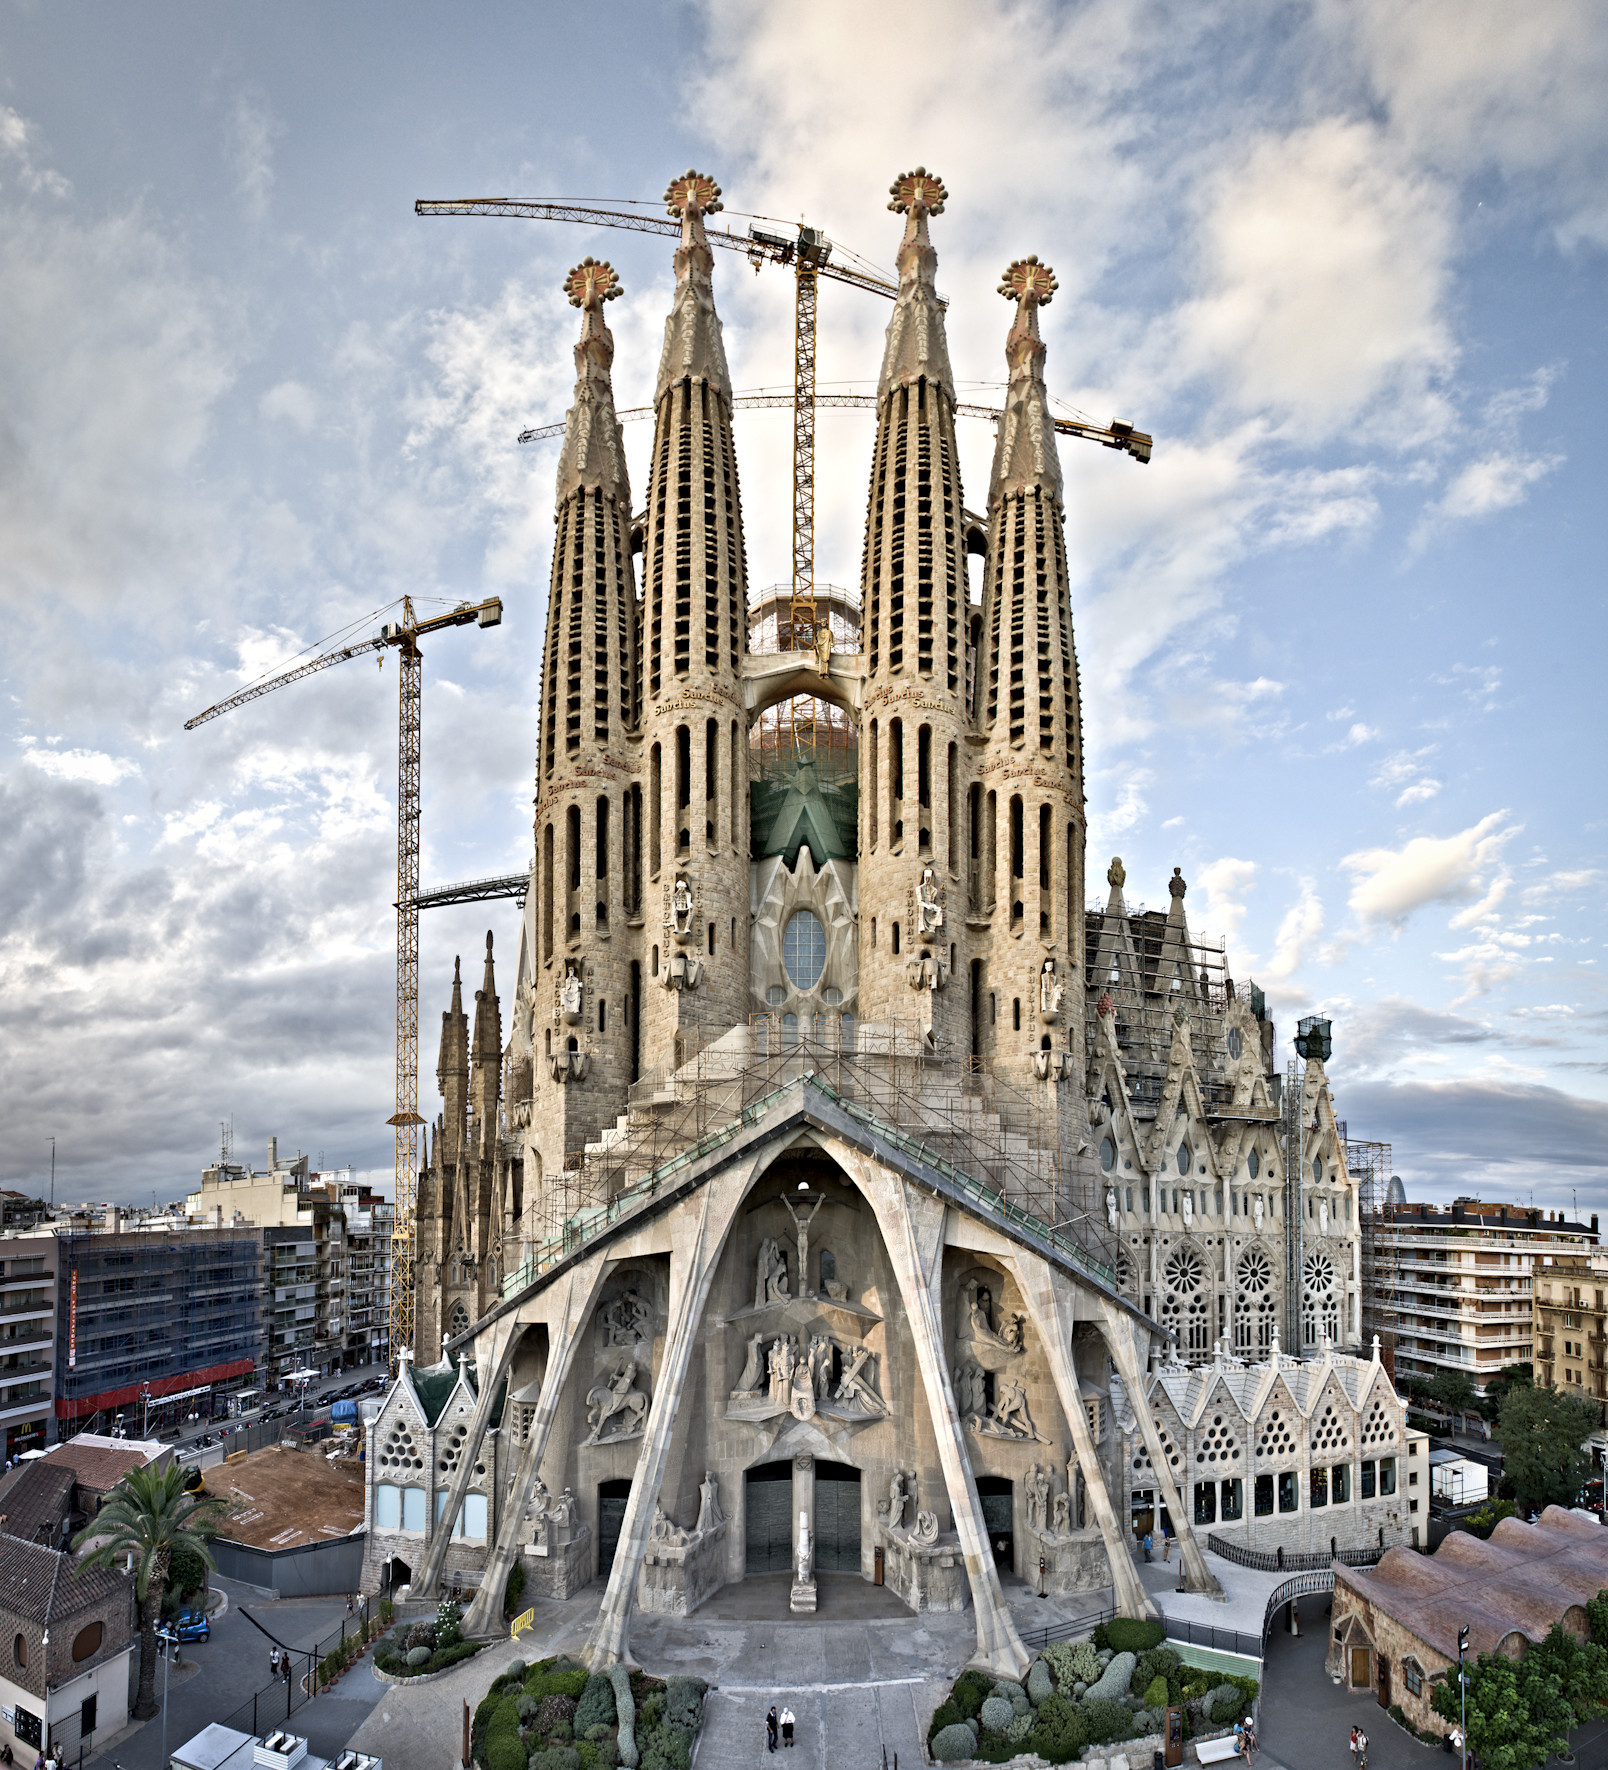Can you describe the main features of this image for me? The image showcases the awe-inspiring Sagrada Familia, an iconic Roman Catholic basilica located in Barcelona, Spain. Captured from a high vantage point, the photograph offers a sweeping view of Antoni Gaudí's architectural masterpiece, which is still undergoing construction. Multiple cranes and scaffolding are visible, emphasizing the ongoing efforts to complete this monumental work.

The church itself is a masterpiece of stone and artistic craftsmanship, with intricate carvings and detailed sculptures adorning its facade. The design features several towering spires, reaching skyward and symbolizing spiritual ascension. The central spire, once completed, will make it the tallest church building in the world.

In the background, the modern cityscape of Barcelona provides a stark contrast to the historic and spiritual grandeur of the Sagrada Familia. Surrounding buildings and bustling streets form the backdrop, creating a juxtaposition between the ancient and the contemporary, reflecting the dynamic spirit of Barcelona. 